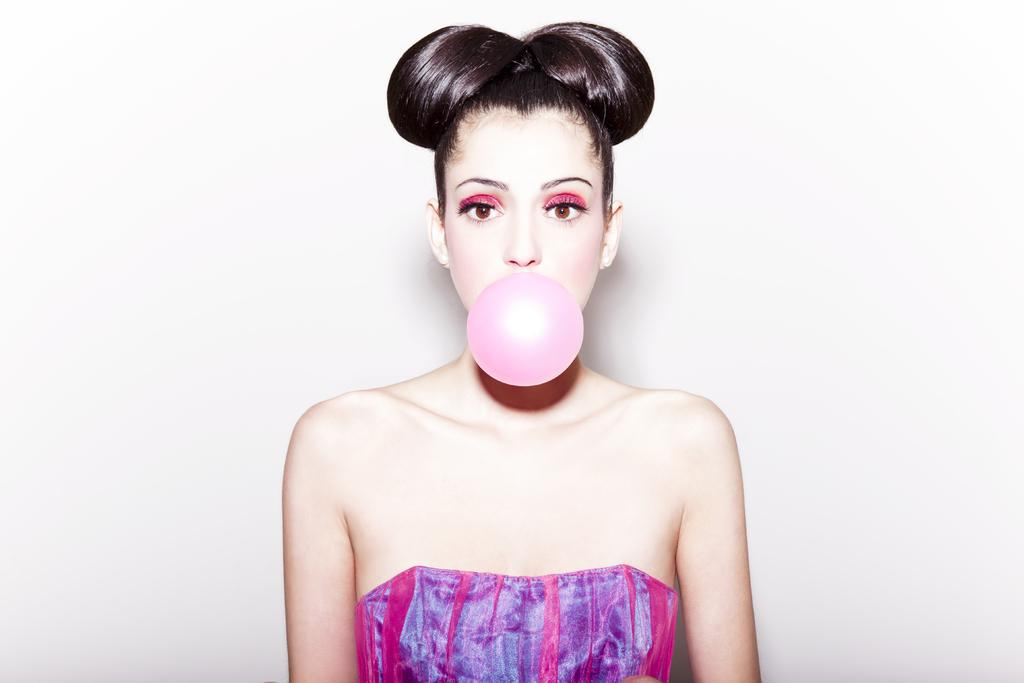Who is present in the image? There is a woman in the image. What is the woman doing in the image? The woman is looking at something. What else can be seen in the image besides the woman? There is a bubble in the image. What is the background of the image like? There is a white wall in the background of the image. What type of fairies can be seen interacting with the woman in the image? There are no fairies present in the image; it only features a woman and a bubble. What kind of trade is being conducted in the image? There is no trade being conducted in the image; it is a simple scene with a woman, a bubble, and a white wall in the background. 